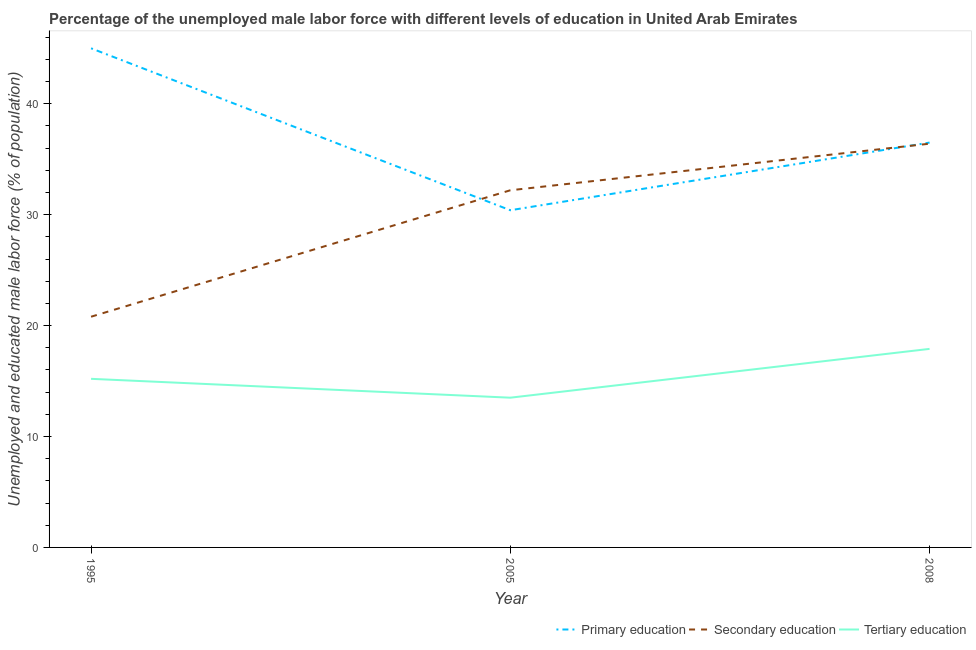How many different coloured lines are there?
Give a very brief answer. 3. What is the percentage of male labor force who received secondary education in 2005?
Provide a short and direct response. 32.2. Across all years, what is the maximum percentage of male labor force who received tertiary education?
Your answer should be very brief. 17.9. Across all years, what is the minimum percentage of male labor force who received primary education?
Make the answer very short. 30.4. In which year was the percentage of male labor force who received primary education maximum?
Keep it short and to the point. 1995. In which year was the percentage of male labor force who received secondary education minimum?
Give a very brief answer. 1995. What is the total percentage of male labor force who received tertiary education in the graph?
Offer a very short reply. 46.6. What is the difference between the percentage of male labor force who received primary education in 2008 and the percentage of male labor force who received tertiary education in 1995?
Your response must be concise. 21.3. What is the average percentage of male labor force who received secondary education per year?
Provide a short and direct response. 29.8. In the year 2005, what is the difference between the percentage of male labor force who received tertiary education and percentage of male labor force who received primary education?
Offer a very short reply. -16.9. What is the ratio of the percentage of male labor force who received tertiary education in 1995 to that in 2008?
Your answer should be compact. 0.85. Is the percentage of male labor force who received secondary education in 1995 less than that in 2005?
Make the answer very short. Yes. What is the difference between the highest and the second highest percentage of male labor force who received tertiary education?
Make the answer very short. 2.7. What is the difference between the highest and the lowest percentage of male labor force who received secondary education?
Ensure brevity in your answer.  15.6. In how many years, is the percentage of male labor force who received tertiary education greater than the average percentage of male labor force who received tertiary education taken over all years?
Offer a very short reply. 1. Is it the case that in every year, the sum of the percentage of male labor force who received primary education and percentage of male labor force who received secondary education is greater than the percentage of male labor force who received tertiary education?
Your answer should be compact. Yes. Is the percentage of male labor force who received primary education strictly greater than the percentage of male labor force who received secondary education over the years?
Provide a succinct answer. No. Is the percentage of male labor force who received tertiary education strictly less than the percentage of male labor force who received secondary education over the years?
Give a very brief answer. Yes. How many years are there in the graph?
Make the answer very short. 3. Does the graph contain any zero values?
Give a very brief answer. No. Where does the legend appear in the graph?
Your response must be concise. Bottom right. How many legend labels are there?
Your response must be concise. 3. How are the legend labels stacked?
Your response must be concise. Horizontal. What is the title of the graph?
Your answer should be compact. Percentage of the unemployed male labor force with different levels of education in United Arab Emirates. What is the label or title of the X-axis?
Make the answer very short. Year. What is the label or title of the Y-axis?
Ensure brevity in your answer.  Unemployed and educated male labor force (% of population). What is the Unemployed and educated male labor force (% of population) in Primary education in 1995?
Your response must be concise. 45. What is the Unemployed and educated male labor force (% of population) of Secondary education in 1995?
Your answer should be very brief. 20.8. What is the Unemployed and educated male labor force (% of population) of Tertiary education in 1995?
Give a very brief answer. 15.2. What is the Unemployed and educated male labor force (% of population) of Primary education in 2005?
Your answer should be very brief. 30.4. What is the Unemployed and educated male labor force (% of population) of Secondary education in 2005?
Ensure brevity in your answer.  32.2. What is the Unemployed and educated male labor force (% of population) of Primary education in 2008?
Offer a very short reply. 36.5. What is the Unemployed and educated male labor force (% of population) in Secondary education in 2008?
Make the answer very short. 36.4. What is the Unemployed and educated male labor force (% of population) of Tertiary education in 2008?
Offer a terse response. 17.9. Across all years, what is the maximum Unemployed and educated male labor force (% of population) in Secondary education?
Offer a terse response. 36.4. Across all years, what is the maximum Unemployed and educated male labor force (% of population) in Tertiary education?
Your response must be concise. 17.9. Across all years, what is the minimum Unemployed and educated male labor force (% of population) of Primary education?
Ensure brevity in your answer.  30.4. Across all years, what is the minimum Unemployed and educated male labor force (% of population) in Secondary education?
Provide a short and direct response. 20.8. Across all years, what is the minimum Unemployed and educated male labor force (% of population) in Tertiary education?
Provide a short and direct response. 13.5. What is the total Unemployed and educated male labor force (% of population) in Primary education in the graph?
Offer a very short reply. 111.9. What is the total Unemployed and educated male labor force (% of population) in Secondary education in the graph?
Your response must be concise. 89.4. What is the total Unemployed and educated male labor force (% of population) in Tertiary education in the graph?
Keep it short and to the point. 46.6. What is the difference between the Unemployed and educated male labor force (% of population) in Primary education in 1995 and that in 2005?
Keep it short and to the point. 14.6. What is the difference between the Unemployed and educated male labor force (% of population) of Tertiary education in 1995 and that in 2005?
Offer a very short reply. 1.7. What is the difference between the Unemployed and educated male labor force (% of population) in Secondary education in 1995 and that in 2008?
Provide a short and direct response. -15.6. What is the difference between the Unemployed and educated male labor force (% of population) in Primary education in 2005 and that in 2008?
Offer a terse response. -6.1. What is the difference between the Unemployed and educated male labor force (% of population) in Tertiary education in 2005 and that in 2008?
Offer a very short reply. -4.4. What is the difference between the Unemployed and educated male labor force (% of population) in Primary education in 1995 and the Unemployed and educated male labor force (% of population) in Secondary education in 2005?
Provide a succinct answer. 12.8. What is the difference between the Unemployed and educated male labor force (% of population) of Primary education in 1995 and the Unemployed and educated male labor force (% of population) of Tertiary education in 2005?
Provide a short and direct response. 31.5. What is the difference between the Unemployed and educated male labor force (% of population) in Secondary education in 1995 and the Unemployed and educated male labor force (% of population) in Tertiary education in 2005?
Your response must be concise. 7.3. What is the difference between the Unemployed and educated male labor force (% of population) in Primary education in 1995 and the Unemployed and educated male labor force (% of population) in Secondary education in 2008?
Give a very brief answer. 8.6. What is the difference between the Unemployed and educated male labor force (% of population) in Primary education in 1995 and the Unemployed and educated male labor force (% of population) in Tertiary education in 2008?
Your response must be concise. 27.1. What is the difference between the Unemployed and educated male labor force (% of population) in Secondary education in 1995 and the Unemployed and educated male labor force (% of population) in Tertiary education in 2008?
Your answer should be compact. 2.9. What is the difference between the Unemployed and educated male labor force (% of population) of Primary education in 2005 and the Unemployed and educated male labor force (% of population) of Secondary education in 2008?
Provide a short and direct response. -6. What is the difference between the Unemployed and educated male labor force (% of population) of Secondary education in 2005 and the Unemployed and educated male labor force (% of population) of Tertiary education in 2008?
Provide a short and direct response. 14.3. What is the average Unemployed and educated male labor force (% of population) of Primary education per year?
Give a very brief answer. 37.3. What is the average Unemployed and educated male labor force (% of population) in Secondary education per year?
Offer a very short reply. 29.8. What is the average Unemployed and educated male labor force (% of population) of Tertiary education per year?
Give a very brief answer. 15.53. In the year 1995, what is the difference between the Unemployed and educated male labor force (% of population) of Primary education and Unemployed and educated male labor force (% of population) of Secondary education?
Your answer should be compact. 24.2. In the year 1995, what is the difference between the Unemployed and educated male labor force (% of population) of Primary education and Unemployed and educated male labor force (% of population) of Tertiary education?
Ensure brevity in your answer.  29.8. In the year 2005, what is the difference between the Unemployed and educated male labor force (% of population) of Primary education and Unemployed and educated male labor force (% of population) of Secondary education?
Your answer should be compact. -1.8. In the year 2008, what is the difference between the Unemployed and educated male labor force (% of population) of Secondary education and Unemployed and educated male labor force (% of population) of Tertiary education?
Your response must be concise. 18.5. What is the ratio of the Unemployed and educated male labor force (% of population) of Primary education in 1995 to that in 2005?
Give a very brief answer. 1.48. What is the ratio of the Unemployed and educated male labor force (% of population) of Secondary education in 1995 to that in 2005?
Provide a succinct answer. 0.65. What is the ratio of the Unemployed and educated male labor force (% of population) of Tertiary education in 1995 to that in 2005?
Keep it short and to the point. 1.13. What is the ratio of the Unemployed and educated male labor force (% of population) in Primary education in 1995 to that in 2008?
Offer a terse response. 1.23. What is the ratio of the Unemployed and educated male labor force (% of population) in Tertiary education in 1995 to that in 2008?
Make the answer very short. 0.85. What is the ratio of the Unemployed and educated male labor force (% of population) of Primary education in 2005 to that in 2008?
Make the answer very short. 0.83. What is the ratio of the Unemployed and educated male labor force (% of population) of Secondary education in 2005 to that in 2008?
Give a very brief answer. 0.88. What is the ratio of the Unemployed and educated male labor force (% of population) in Tertiary education in 2005 to that in 2008?
Your answer should be very brief. 0.75. What is the difference between the highest and the lowest Unemployed and educated male labor force (% of population) of Primary education?
Provide a short and direct response. 14.6. 